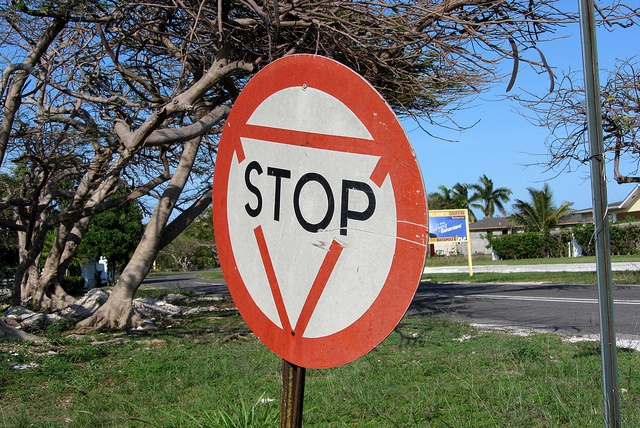Describe the objects in this image and their specific colors. I can see a stop sign in blue, lightgray, red, and brown tones in this image. 